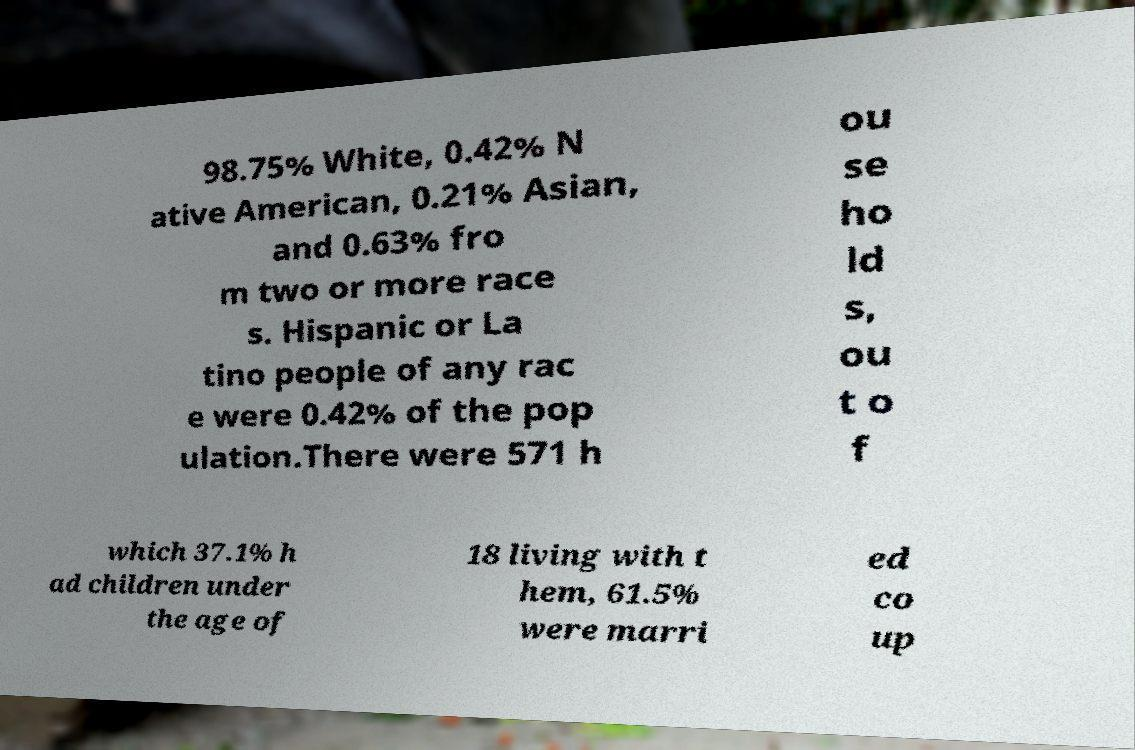Please read and relay the text visible in this image. What does it say? 98.75% White, 0.42% N ative American, 0.21% Asian, and 0.63% fro m two or more race s. Hispanic or La tino people of any rac e were 0.42% of the pop ulation.There were 571 h ou se ho ld s, ou t o f which 37.1% h ad children under the age of 18 living with t hem, 61.5% were marri ed co up 